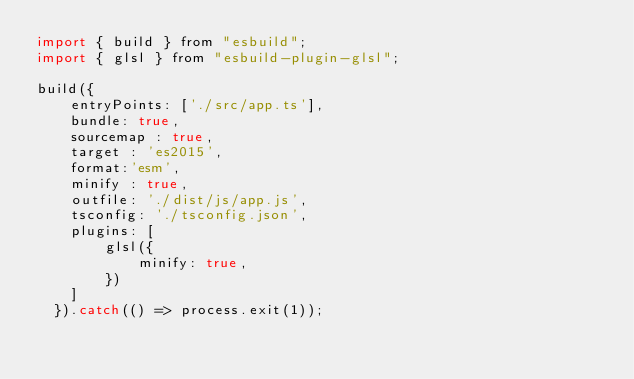<code> <loc_0><loc_0><loc_500><loc_500><_JavaScript_>import { build } from "esbuild";
import { glsl } from "esbuild-plugin-glsl";

build({
    entryPoints: ['./src/app.ts'],
    bundle: true,
    sourcemap : true,
    target : 'es2015',
    format:'esm',
    minify : true,
    outfile: './dist/js/app.js',
    tsconfig: './tsconfig.json',
    plugins: [
        glsl({
            minify: true,
        })
    ]
  }).catch(() => process.exit(1));</code> 